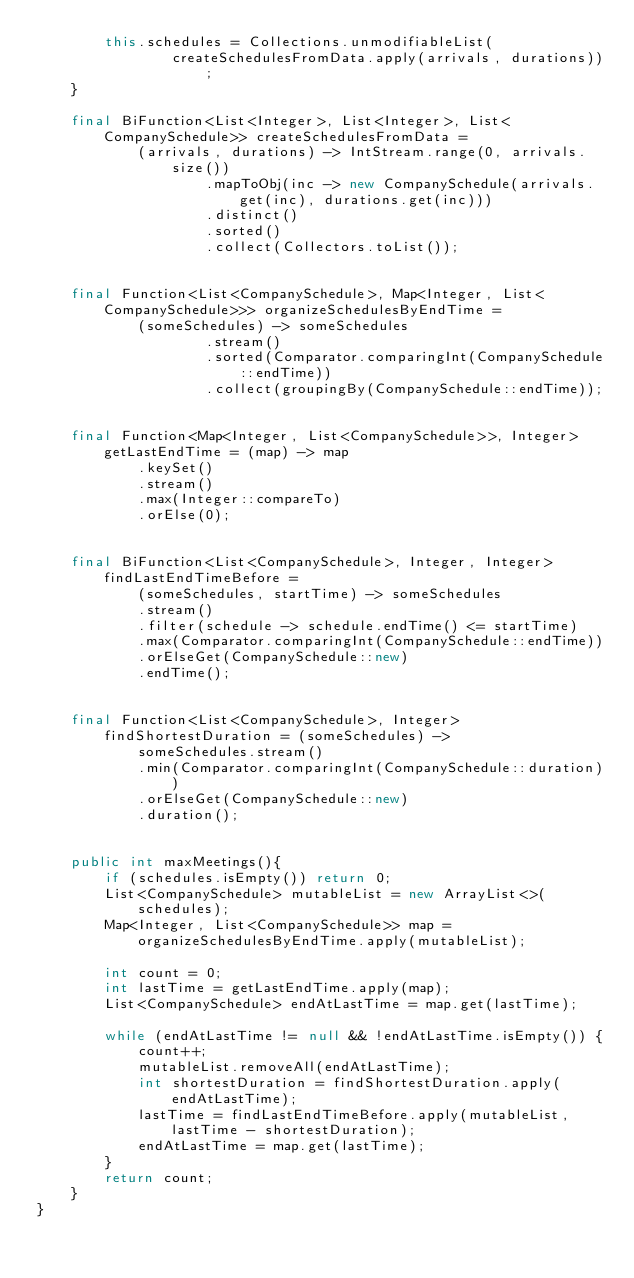<code> <loc_0><loc_0><loc_500><loc_500><_Java_>		this.schedules = Collections.unmodifiableList(
				createSchedulesFromData.apply(arrivals, durations));
	}

	final BiFunction<List<Integer>, List<Integer>, List<CompanySchedule>> createSchedulesFromData =
			(arrivals, durations) -> IntStream.range(0, arrivals.size())
					.mapToObj(inc -> new CompanySchedule(arrivals.get(inc), durations.get(inc)))
					.distinct()
					.sorted()
					.collect(Collectors.toList());


	final Function<List<CompanySchedule>, Map<Integer, List<CompanySchedule>>> organizeSchedulesByEndTime =
			(someSchedules) -> someSchedules
					.stream()
					.sorted(Comparator.comparingInt(CompanySchedule::endTime))
					.collect(groupingBy(CompanySchedule::endTime));


	final Function<Map<Integer, List<CompanySchedule>>, Integer> getLastEndTime = (map) -> map
			.keySet()
			.stream()
			.max(Integer::compareTo)
			.orElse(0);


	final BiFunction<List<CompanySchedule>, Integer, Integer> findLastEndTimeBefore =
			(someSchedules, startTime) -> someSchedules
			.stream()
			.filter(schedule -> schedule.endTime() <= startTime)
			.max(Comparator.comparingInt(CompanySchedule::endTime))
			.orElseGet(CompanySchedule::new)
			.endTime();


	final Function<List<CompanySchedule>, Integer> findShortestDuration = (someSchedules) ->
			someSchedules.stream()
			.min(Comparator.comparingInt(CompanySchedule::duration))
			.orElseGet(CompanySchedule::new)
			.duration();


	public int maxMeetings(){
		if (schedules.isEmpty()) return 0;
		List<CompanySchedule> mutableList = new ArrayList<>(schedules);
		Map<Integer, List<CompanySchedule>> map = organizeSchedulesByEndTime.apply(mutableList);

		int count = 0;
		int lastTime = getLastEndTime.apply(map);
		List<CompanySchedule> endAtLastTime = map.get(lastTime);

		while (endAtLastTime != null && !endAtLastTime.isEmpty()) {
			count++;
			mutableList.removeAll(endAtLastTime);
			int shortestDuration = findShortestDuration.apply(endAtLastTime);
			lastTime = findLastEndTimeBefore.apply(mutableList, lastTime - shortestDuration);
			endAtLastTime = map.get(lastTime);
		}
		return count;
	}
}
</code> 